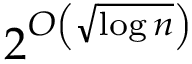Convert formula to latex. <formula><loc_0><loc_0><loc_500><loc_500>2 ^ { O \left ( { \sqrt { \log n } } \right ) }</formula> 